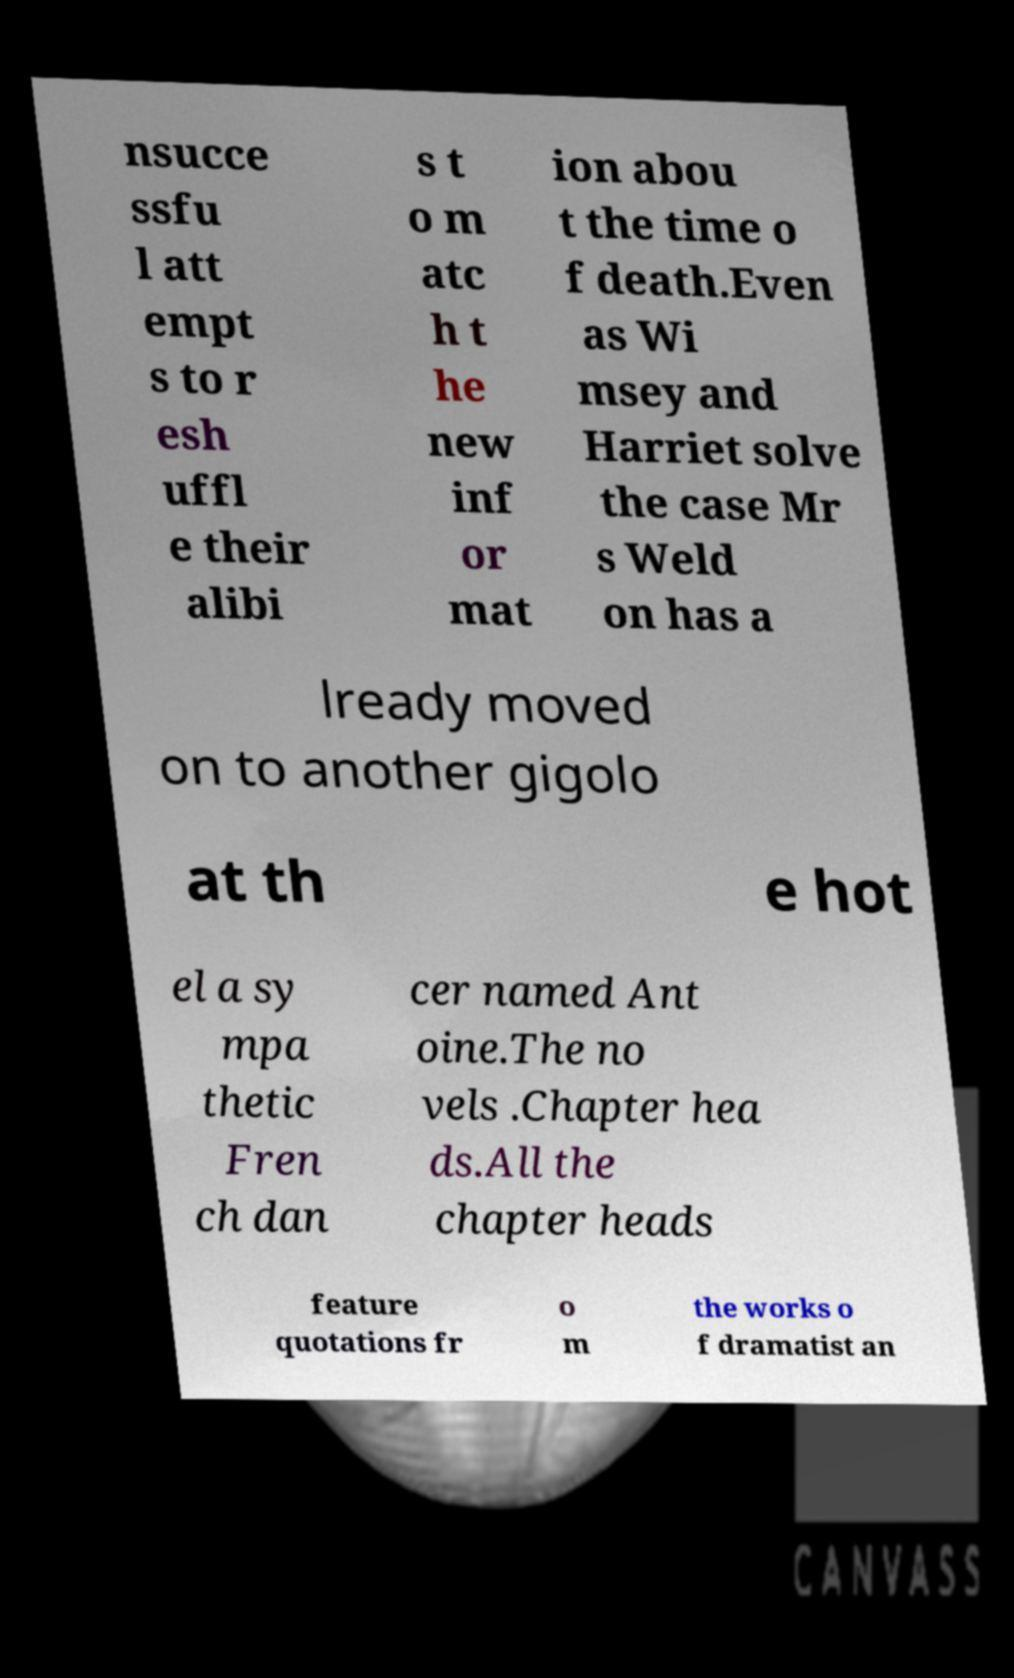Can you read and provide the text displayed in the image?This photo seems to have some interesting text. Can you extract and type it out for me? nsucce ssfu l att empt s to r esh uffl e their alibi s t o m atc h t he new inf or mat ion abou t the time o f death.Even as Wi msey and Harriet solve the case Mr s Weld on has a lready moved on to another gigolo at th e hot el a sy mpa thetic Fren ch dan cer named Ant oine.The no vels .Chapter hea ds.All the chapter heads feature quotations fr o m the works o f dramatist an 